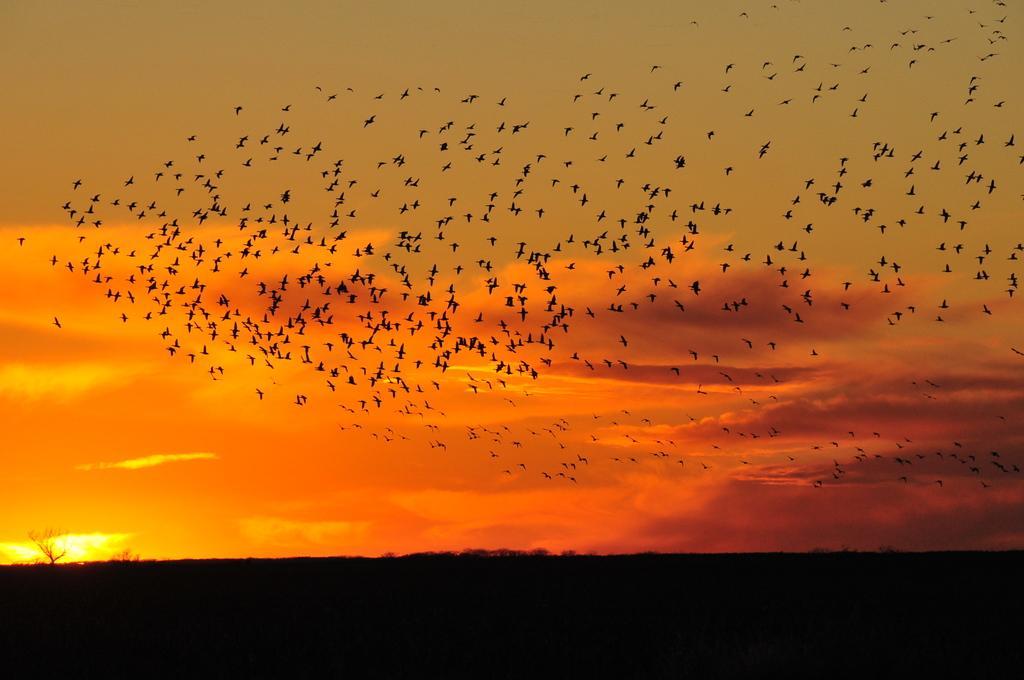In one or two sentences, can you explain what this image depicts? There are many birds flying in the sky. The sky is in orange color. At the bottom of the picture, it is black in color. 